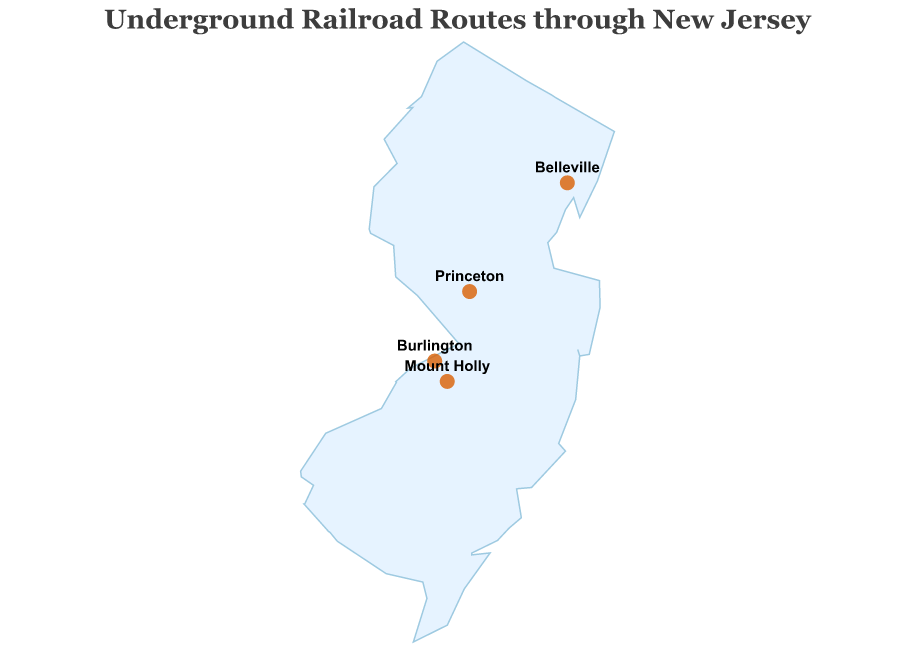What is the title of the figure? The title is clearly visible at the top of the figure. It reads "Underground Railroad Routes through New Jersey".
Answer: Underground Railroad Routes through New Jersey How many data points (locations) are marked on the map? By visually scanning the map, there are a total of four locations marked with circles.
Answer: Four Which location has the highest latitude? Comparing the latitude values of the marked locations (Burlington, Princeton, Belleville, Mount Holly), Belleville has the highest latitude (40.7937).
Answer: Belleville What is the description of the marked location in Princeton? Hovering or referring to the tooltip for Princeton reveals the description as "Refuge at Witherspoon Street Presbyterian Church".
Answer: Refuge at Witherspoon Street Presbyterian Church Which two locations are closest to each other in terms of longitude? By examining the longitude values (Burlington -74.8516, Princeton -74.6672, Belleville -74.1507, Mount Holly -74.7854), Burlington and Mount Holly are closest to each other with longitudes -74.8516 and -74.7854.
Answer: Burlington and Mount Holly Compare the latitude of Burlington and Mount Holly. Which one is greater? Looking at the latitude values (Burlington 40.0768, Mount Holly 39.9943), Burlington has a greater latitude.
Answer: Burlington What kind of landmark is located in Belleville? Referring to the tooltip or description for Belleville, it mentions a "Safe house at Dutch Reformed Church".
Answer: Dutch Reformed Church What is common about the role of locations in Burlington and Mount Holly? By examining the descriptions for Burlington ("Quaker-run safe house and starting point for many routes") and Mount Holly ("Quaker meetinghouse used as safe haven"), both are associated with Quaker-run safe houses.
Answer: Quaker-run safe houses Which location is located at approximately 40.3573 latitude? By locating the latitude 40.3573 on the map, it corresponds to Princeton.
Answer: Princeton How are the routes of the Underground Railroad represented on the map of New Jersey? The routes are represented by marked points with descriptions on a map showing New Jersey, with additional textual labels for each location.
Answer: Points with descriptions and labels 